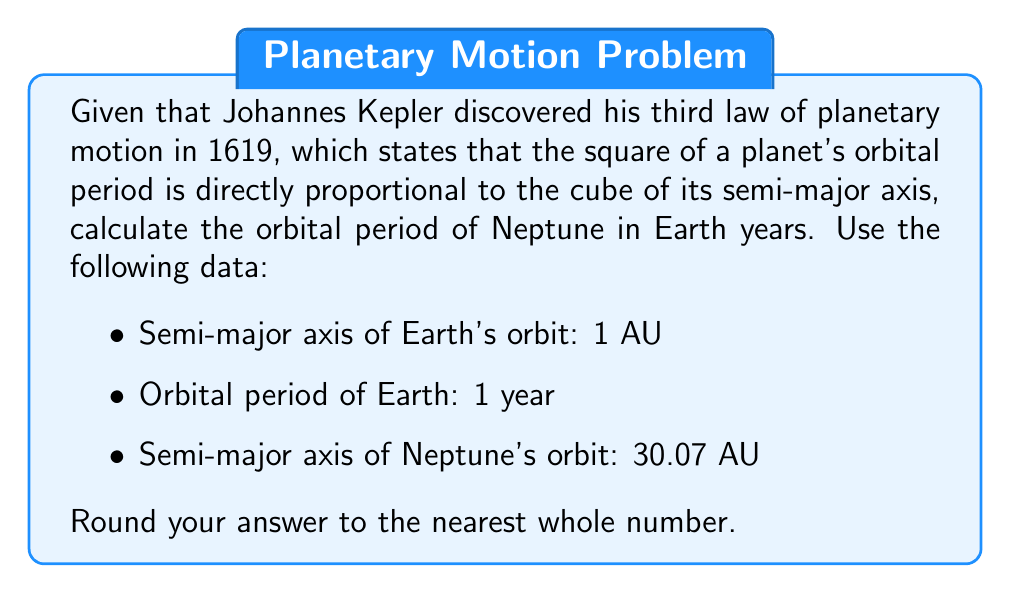Show me your answer to this math problem. Let's approach this step-by-step using Kepler's Third Law:

1) Kepler's Third Law can be expressed as:

   $$\frac{T_1^2}{a_1^3} = \frac{T_2^2}{a_2^3}$$

   Where $T$ is the orbital period and $a$ is the semi-major axis.

2) Let's use Earth as planet 1 and Neptune as planet 2:

   $$\frac{1^2}{1^3} = \frac{T_N^2}{30.07^3}$$

   Where $T_N$ is Neptune's orbital period in Earth years.

3) Simplify the left side:

   $$1 = \frac{T_N^2}{30.07^3}$$

4) Multiply both sides by $30.07^3$:

   $$30.07^3 = T_N^2$$

5) Take the square root of both sides:

   $$\sqrt{30.07^3} = T_N$$

6) Calculate:

   $$T_N = 30.07^{3/2} \approx 164.79$$

7) Rounding to the nearest whole number:

   $$T_N \approx 165$$
Answer: 165 years 